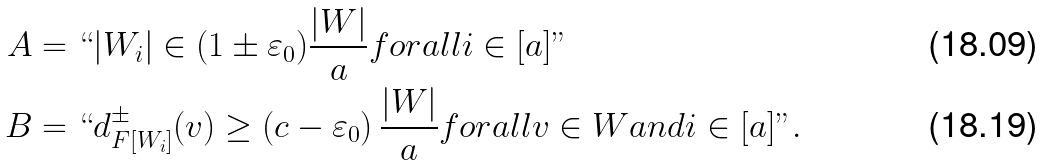<formula> <loc_0><loc_0><loc_500><loc_500>A & = ` ` | W _ { i } | \in ( 1 \pm \varepsilon _ { 0 } ) \frac { | W | } { a } f o r a l l i \in [ a ] " \\ B & = ` ` d ^ { \pm } _ { F [ W _ { i } ] } ( v ) \geq \left ( c - \varepsilon _ { 0 } \right ) \frac { | W | } { a } f o r a l l v \in W a n d i \in [ a ] " .</formula> 